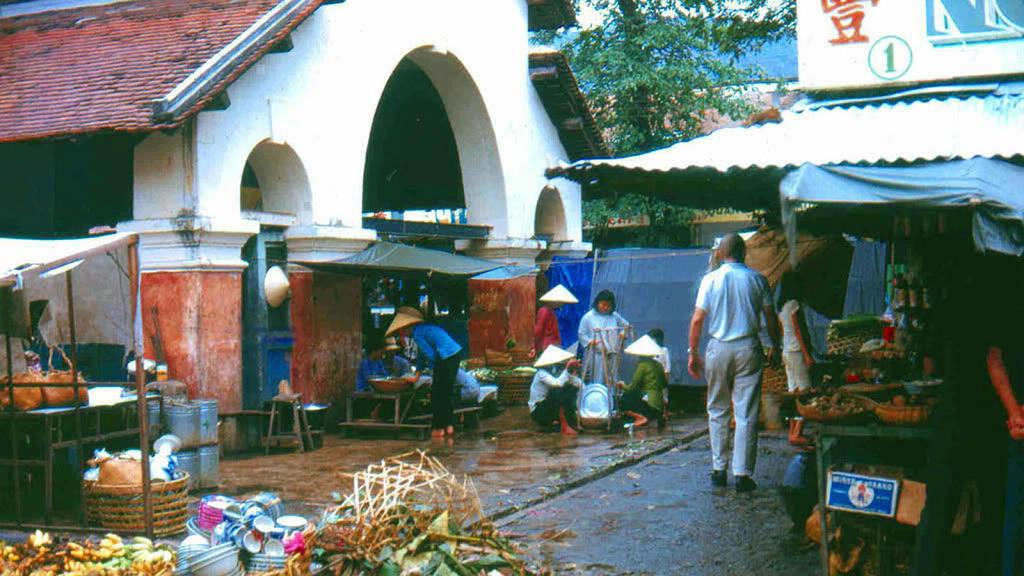What is the man in the image doing? The man is walking on the right side of the image. What structure can be seen on the left side of the image? There is a house on the left side of the image. What is located in the middle of the image? There is a tree in the middle of the image. What type of shelter is visible in the image? There is a tent in the image. What type of scarecrow can be seen standing near the tree in the image? There is no scarecrow present in the image; it features a man walking, a house, a tree, and a tent. Is it raining in the image? The provided facts do not mention any weather conditions, so we cannot determine if it is raining or not. 